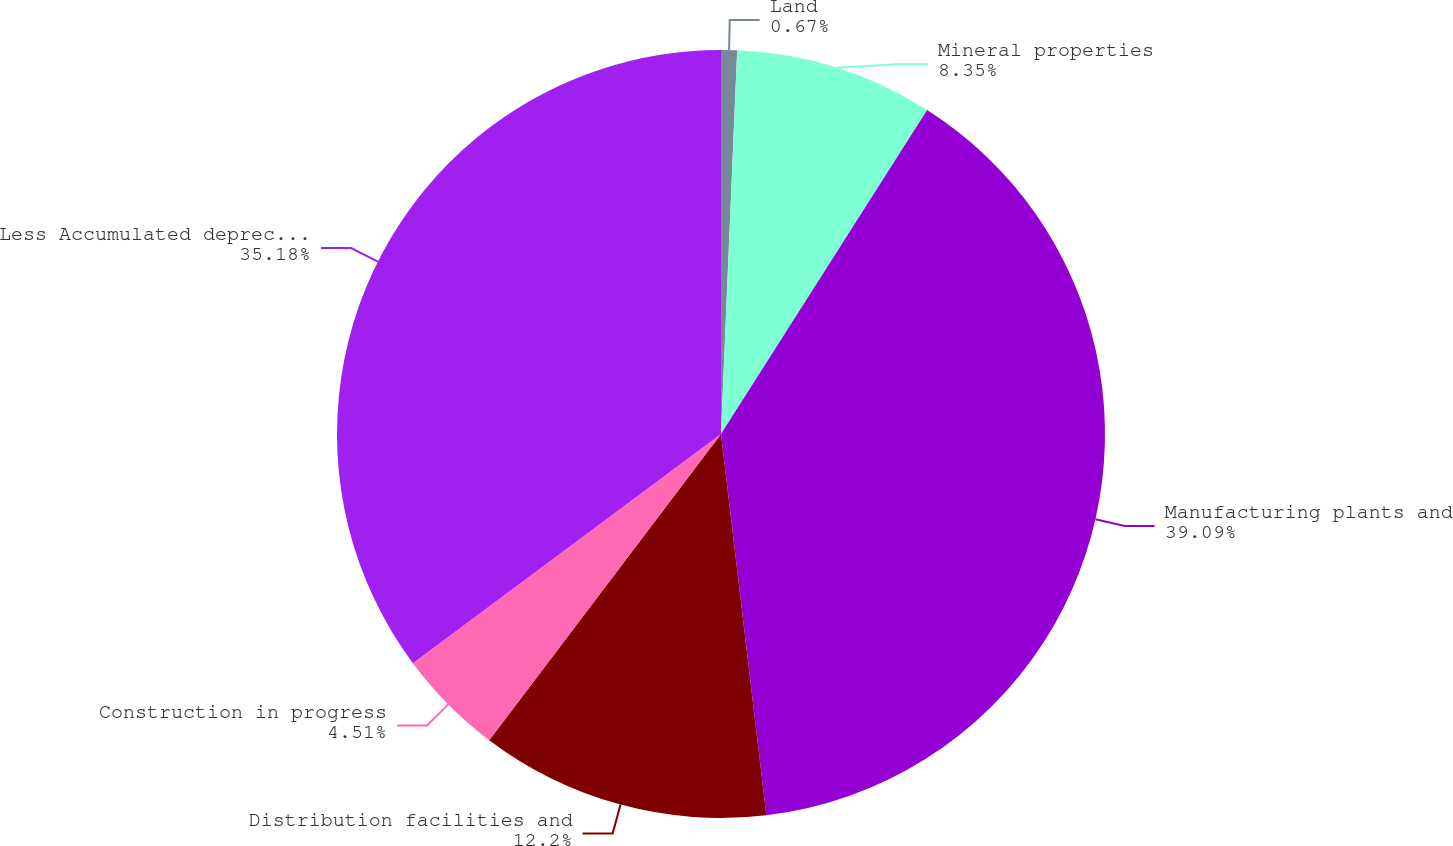Convert chart to OTSL. <chart><loc_0><loc_0><loc_500><loc_500><pie_chart><fcel>Land<fcel>Mineral properties<fcel>Manufacturing plants and<fcel>Distribution facilities and<fcel>Construction in progress<fcel>Less Accumulated depreciation<nl><fcel>0.67%<fcel>8.35%<fcel>39.1%<fcel>12.2%<fcel>4.51%<fcel>35.18%<nl></chart> 